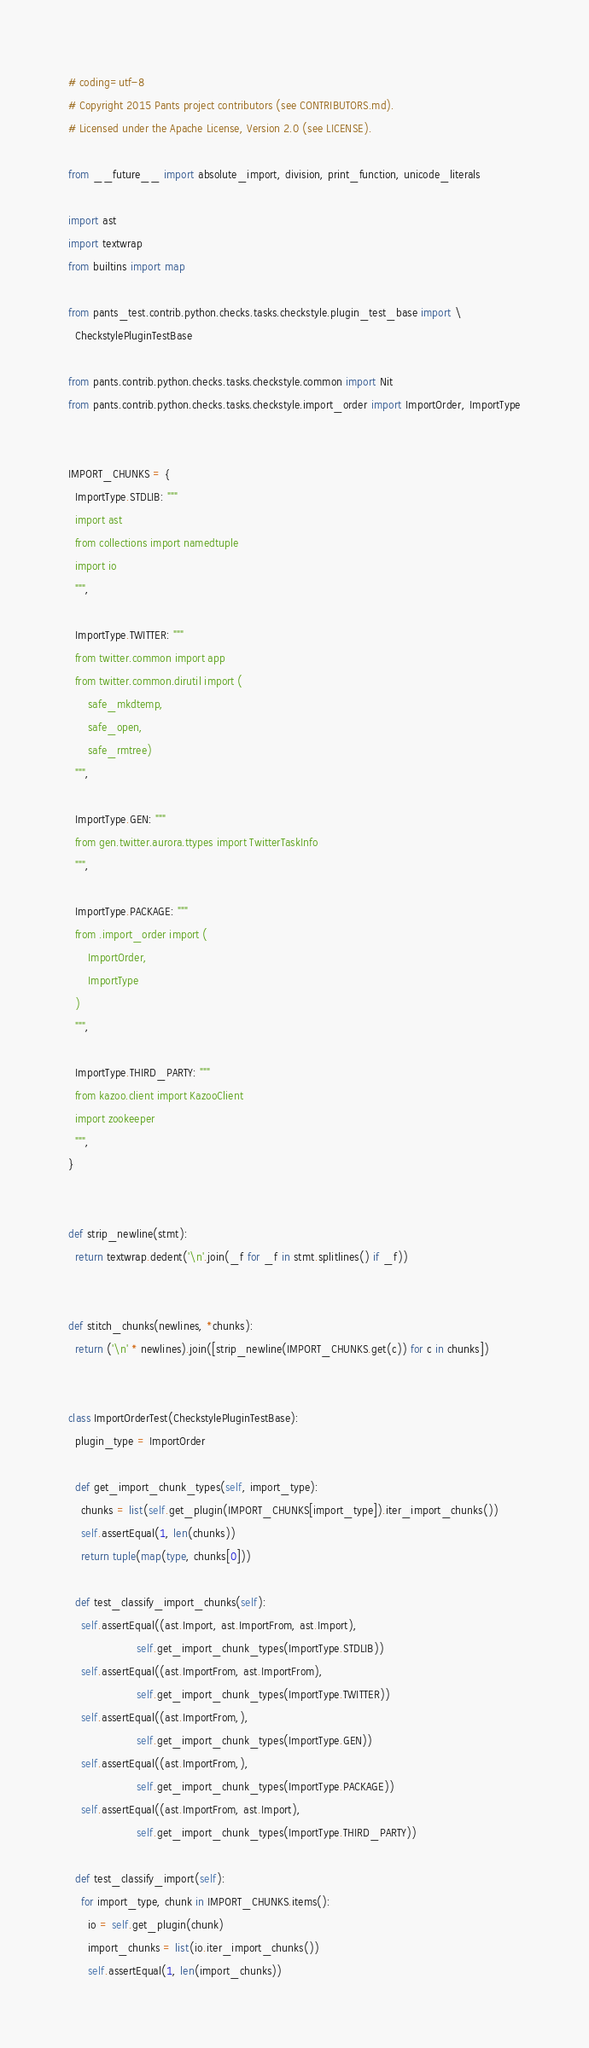Convert code to text. <code><loc_0><loc_0><loc_500><loc_500><_Python_># coding=utf-8
# Copyright 2015 Pants project contributors (see CONTRIBUTORS.md).
# Licensed under the Apache License, Version 2.0 (see LICENSE).

from __future__ import absolute_import, division, print_function, unicode_literals

import ast
import textwrap
from builtins import map

from pants_test.contrib.python.checks.tasks.checkstyle.plugin_test_base import \
  CheckstylePluginTestBase

from pants.contrib.python.checks.tasks.checkstyle.common import Nit
from pants.contrib.python.checks.tasks.checkstyle.import_order import ImportOrder, ImportType


IMPORT_CHUNKS = {
  ImportType.STDLIB: """
  import ast
  from collections import namedtuple
  import io
  """,

  ImportType.TWITTER: """
  from twitter.common import app
  from twitter.common.dirutil import (
      safe_mkdtemp,
      safe_open,
      safe_rmtree)
  """,

  ImportType.GEN: """
  from gen.twitter.aurora.ttypes import TwitterTaskInfo
  """,

  ImportType.PACKAGE: """
  from .import_order import (
      ImportOrder,
      ImportType
  )
  """,

  ImportType.THIRD_PARTY: """
  from kazoo.client import KazooClient
  import zookeeper
  """,
}


def strip_newline(stmt):
  return textwrap.dedent('\n'.join(_f for _f in stmt.splitlines() if _f))


def stitch_chunks(newlines, *chunks):
  return ('\n' * newlines).join([strip_newline(IMPORT_CHUNKS.get(c)) for c in chunks])


class ImportOrderTest(CheckstylePluginTestBase):
  plugin_type = ImportOrder

  def get_import_chunk_types(self, import_type):
    chunks = list(self.get_plugin(IMPORT_CHUNKS[import_type]).iter_import_chunks())
    self.assertEqual(1, len(chunks))
    return tuple(map(type, chunks[0]))

  def test_classify_import_chunks(self):
    self.assertEqual((ast.Import, ast.ImportFrom, ast.Import),
                     self.get_import_chunk_types(ImportType.STDLIB))
    self.assertEqual((ast.ImportFrom, ast.ImportFrom),
                     self.get_import_chunk_types(ImportType.TWITTER))
    self.assertEqual((ast.ImportFrom,),
                     self.get_import_chunk_types(ImportType.GEN))
    self.assertEqual((ast.ImportFrom,),
                     self.get_import_chunk_types(ImportType.PACKAGE))
    self.assertEqual((ast.ImportFrom, ast.Import),
                     self.get_import_chunk_types(ImportType.THIRD_PARTY))

  def test_classify_import(self):
    for import_type, chunk in IMPORT_CHUNKS.items():
      io = self.get_plugin(chunk)
      import_chunks = list(io.iter_import_chunks())
      self.assertEqual(1, len(import_chunks))</code> 